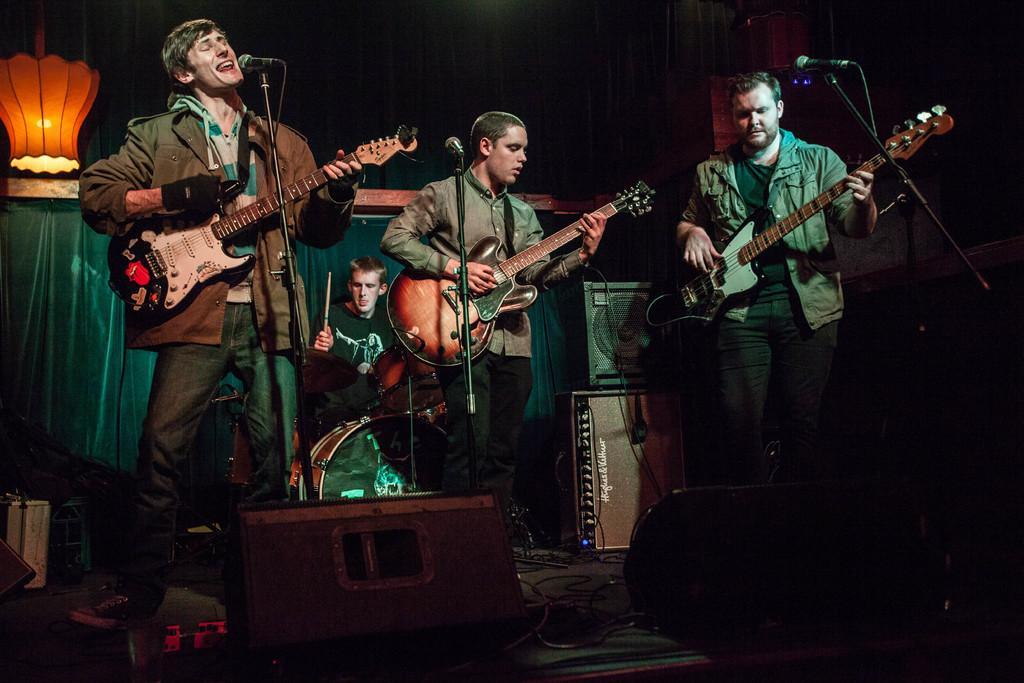In one or two sentences, can you explain what this image depicts? There are four people on the stage performing by singing on mic and playing musical instruments. In the background there is a light and a banner. 